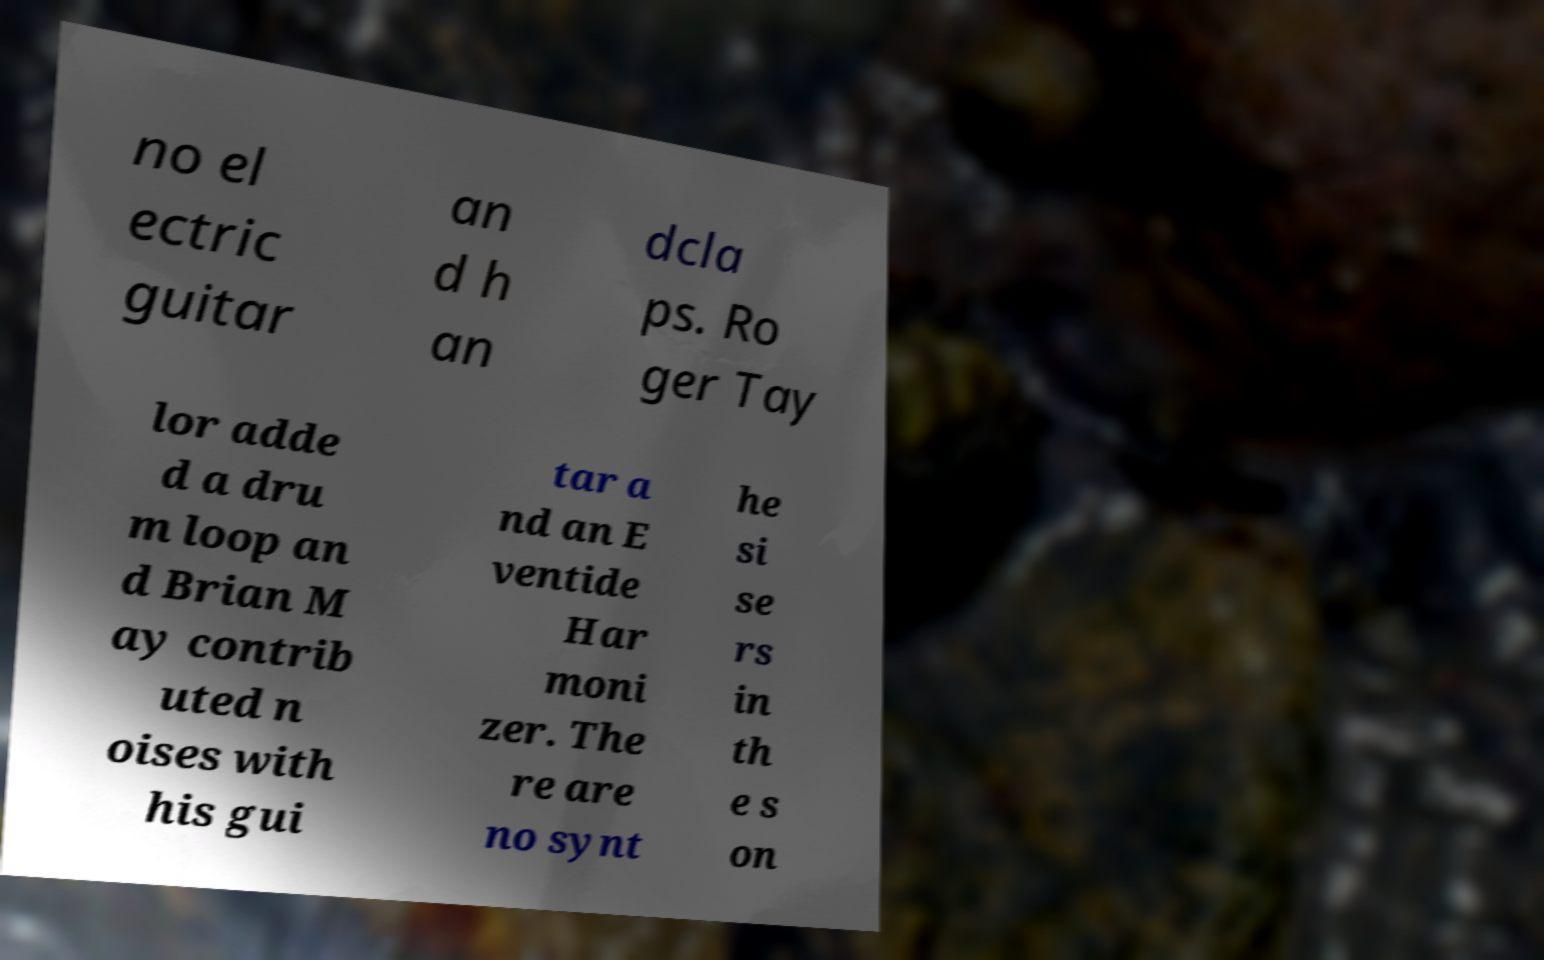Please read and relay the text visible in this image. What does it say? no el ectric guitar an d h an dcla ps. Ro ger Tay lor adde d a dru m loop an d Brian M ay contrib uted n oises with his gui tar a nd an E ventide Har moni zer. The re are no synt he si se rs in th e s on 